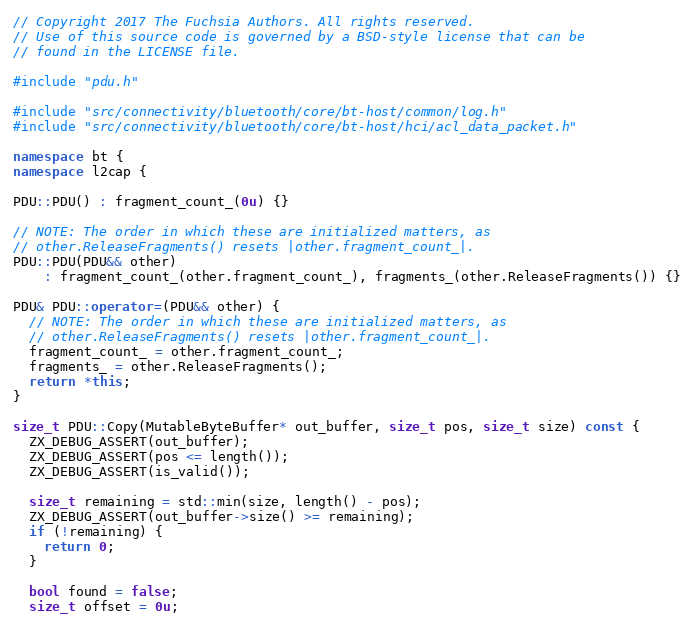<code> <loc_0><loc_0><loc_500><loc_500><_C++_>// Copyright 2017 The Fuchsia Authors. All rights reserved.
// Use of this source code is governed by a BSD-style license that can be
// found in the LICENSE file.

#include "pdu.h"

#include "src/connectivity/bluetooth/core/bt-host/common/log.h"
#include "src/connectivity/bluetooth/core/bt-host/hci/acl_data_packet.h"

namespace bt {
namespace l2cap {

PDU::PDU() : fragment_count_(0u) {}

// NOTE: The order in which these are initialized matters, as
// other.ReleaseFragments() resets |other.fragment_count_|.
PDU::PDU(PDU&& other)
    : fragment_count_(other.fragment_count_), fragments_(other.ReleaseFragments()) {}

PDU& PDU::operator=(PDU&& other) {
  // NOTE: The order in which these are initialized matters, as
  // other.ReleaseFragments() resets |other.fragment_count_|.
  fragment_count_ = other.fragment_count_;
  fragments_ = other.ReleaseFragments();
  return *this;
}

size_t PDU::Copy(MutableByteBuffer* out_buffer, size_t pos, size_t size) const {
  ZX_DEBUG_ASSERT(out_buffer);
  ZX_DEBUG_ASSERT(pos <= length());
  ZX_DEBUG_ASSERT(is_valid());

  size_t remaining = std::min(size, length() - pos);
  ZX_DEBUG_ASSERT(out_buffer->size() >= remaining);
  if (!remaining) {
    return 0;
  }

  bool found = false;
  size_t offset = 0u;</code> 